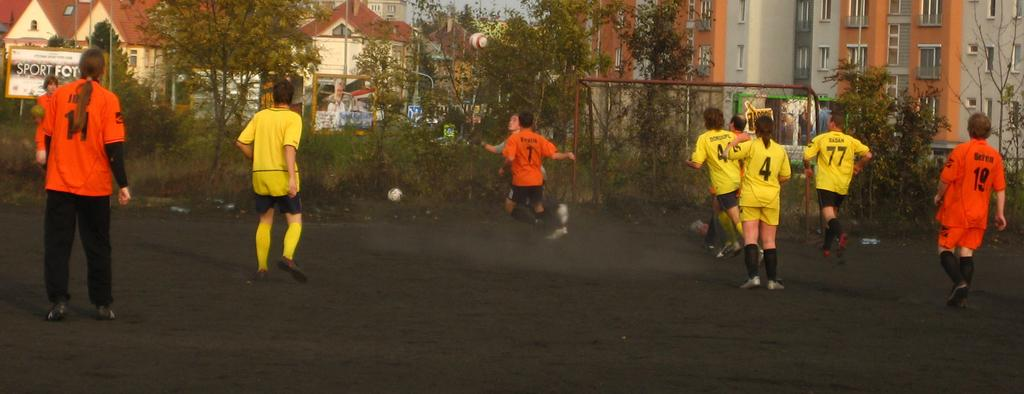What activity are the people in the image engaged in? The people in the image are playing football. Where are the people playing football in the image? The people are playing football at the bottom of the image. What can be seen in the background of the image? There are trees and buildings in the background of the image. How many balls are visible in the image? There are balls visible in the image. What is present in the background of the image that is related to football? There is a goal net in the background of the image. What type of berry is being used as a football in the image? There is no berry being used as a football in the image; the people are playing with a regular football. 